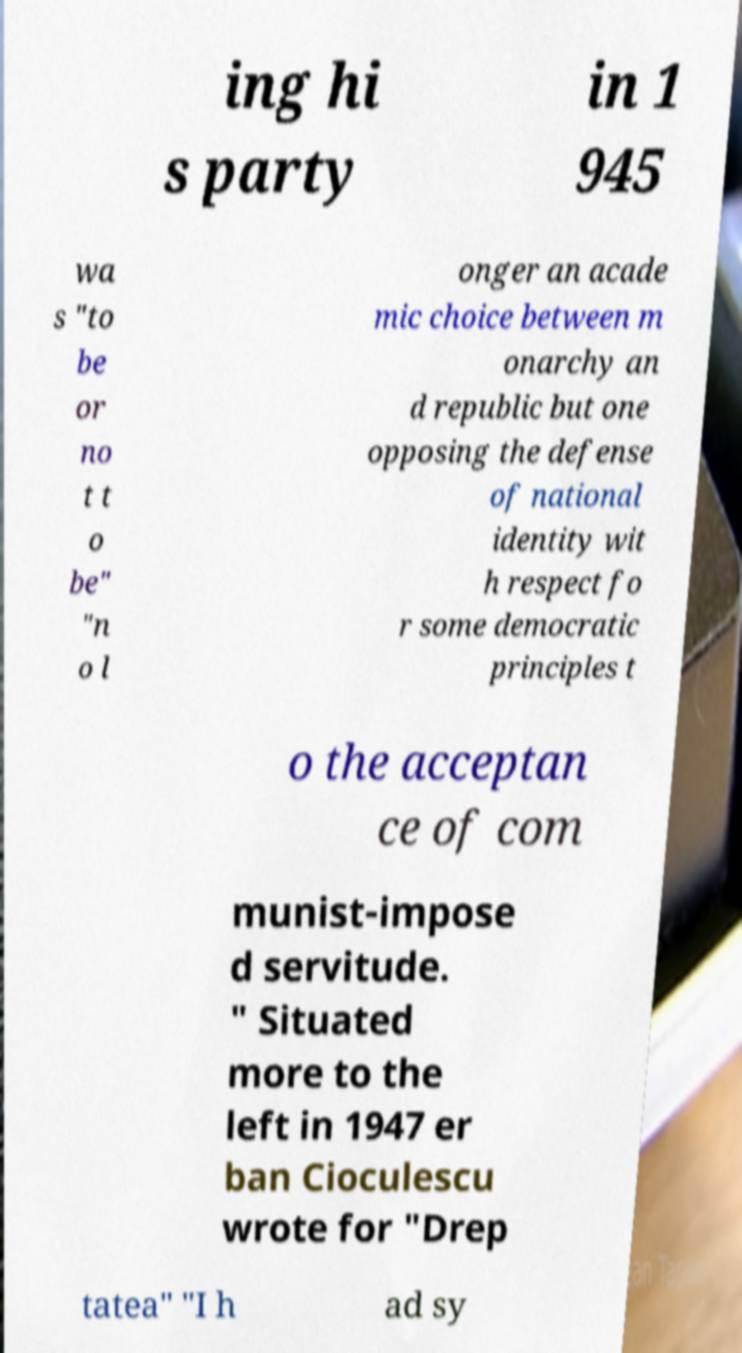I need the written content from this picture converted into text. Can you do that? ing hi s party in 1 945 wa s "to be or no t t o be" "n o l onger an acade mic choice between m onarchy an d republic but one opposing the defense of national identity wit h respect fo r some democratic principles t o the acceptan ce of com munist-impose d servitude. " Situated more to the left in 1947 er ban Cioculescu wrote for "Drep tatea" "I h ad sy 